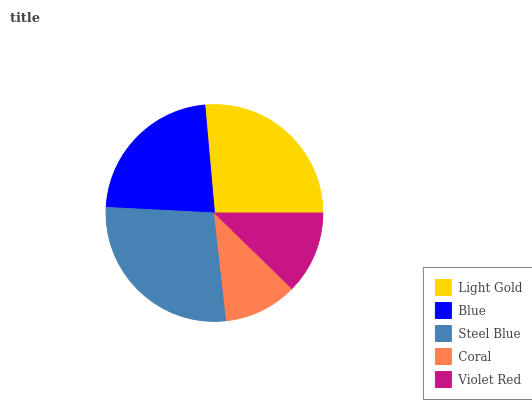Is Coral the minimum?
Answer yes or no. Yes. Is Steel Blue the maximum?
Answer yes or no. Yes. Is Blue the minimum?
Answer yes or no. No. Is Blue the maximum?
Answer yes or no. No. Is Light Gold greater than Blue?
Answer yes or no. Yes. Is Blue less than Light Gold?
Answer yes or no. Yes. Is Blue greater than Light Gold?
Answer yes or no. No. Is Light Gold less than Blue?
Answer yes or no. No. Is Blue the high median?
Answer yes or no. Yes. Is Blue the low median?
Answer yes or no. Yes. Is Steel Blue the high median?
Answer yes or no. No. Is Violet Red the low median?
Answer yes or no. No. 